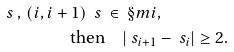<formula> <loc_0><loc_0><loc_500><loc_500>\ s \, , \, ( i , i + 1 ) \ s \, & \in \, \S m i , \\ \text {then} & \quad | \ s _ { i + 1 } - \ s _ { i } | \geq 2 .</formula> 